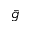Convert formula to latex. <formula><loc_0><loc_0><loc_500><loc_500>\bar { g }</formula> 